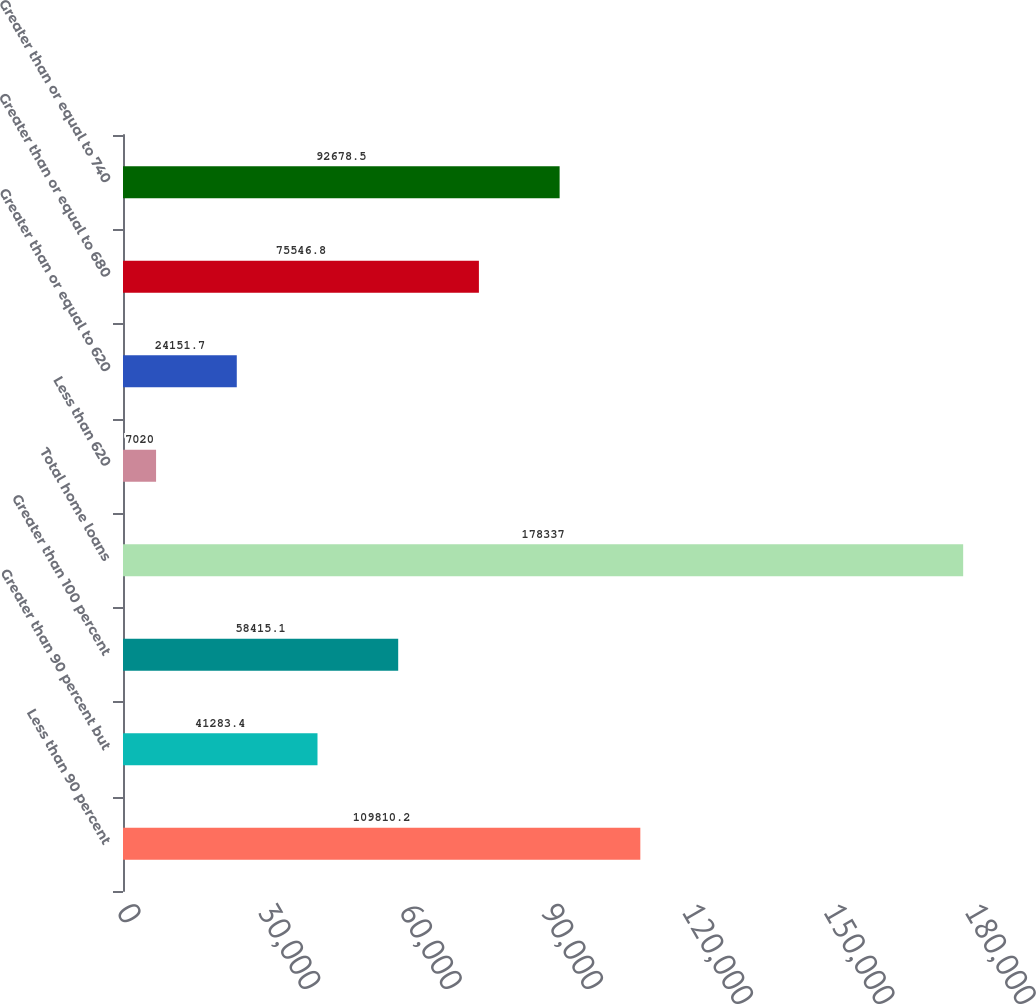Convert chart. <chart><loc_0><loc_0><loc_500><loc_500><bar_chart><fcel>Less than 90 percent<fcel>Greater than 90 percent but<fcel>Greater than 100 percent<fcel>Total home loans<fcel>Less than 620<fcel>Greater than or equal to 620<fcel>Greater than or equal to 680<fcel>Greater than or equal to 740<nl><fcel>109810<fcel>41283.4<fcel>58415.1<fcel>178337<fcel>7020<fcel>24151.7<fcel>75546.8<fcel>92678.5<nl></chart> 